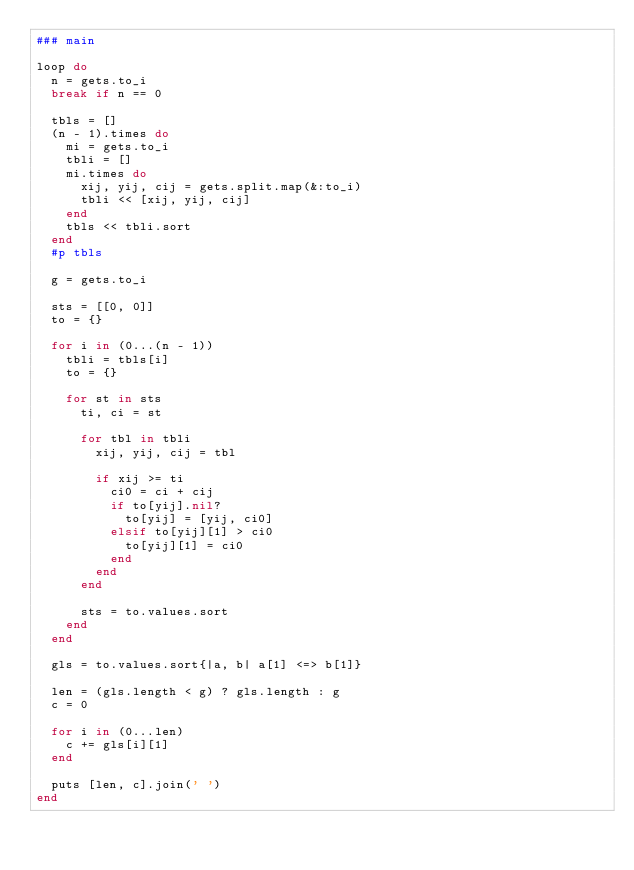<code> <loc_0><loc_0><loc_500><loc_500><_Ruby_>### main

loop do
  n = gets.to_i
  break if n == 0

  tbls = []
  (n - 1).times do
    mi = gets.to_i
    tbli = []
    mi.times do
      xij, yij, cij = gets.split.map(&:to_i)
      tbli << [xij, yij, cij]
    end
    tbls << tbli.sort
  end
  #p tbls

  g = gets.to_i

  sts = [[0, 0]]
  to = {}

  for i in (0...(n - 1))
    tbli = tbls[i]
    to = {}

    for st in sts
      ti, ci = st

      for tbl in tbli
        xij, yij, cij = tbl

        if xij >= ti
          ci0 = ci + cij
          if to[yij].nil?
            to[yij] = [yij, ci0]
          elsif to[yij][1] > ci0
            to[yij][1] = ci0
          end
        end
      end

      sts = to.values.sort
    end
  end

  gls = to.values.sort{|a, b| a[1] <=> b[1]}

  len = (gls.length < g) ? gls.length : g
  c = 0

  for i in (0...len)
    c += gls[i][1]
  end

  puts [len, c].join(' ')
end</code> 